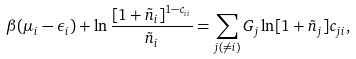Convert formula to latex. <formula><loc_0><loc_0><loc_500><loc_500>\beta ( \mu _ { i } - \epsilon _ { i } ) + \ln \frac { [ 1 + \tilde { n } _ { i } ] ^ { 1 - c _ { i i } } } { \tilde { n } _ { i } } = \sum _ { j ( \ne i ) } G _ { j } \ln [ 1 + \tilde { n } _ { j } ] c _ { j i } ,</formula> 